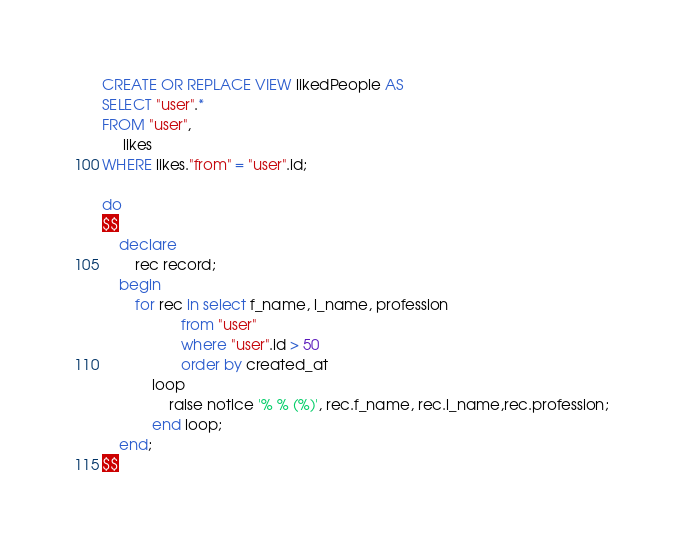Convert code to text. <code><loc_0><loc_0><loc_500><loc_500><_SQL_>CREATE OR REPLACE VIEW likedPeople AS
SELECT "user".*
FROM "user",
     likes
WHERE likes."from" = "user".id;

do
$$
    declare
        rec record;
    begin
        for rec in select f_name, l_name, profession
                   from "user"
                   where "user".id > 50
                   order by created_at
            loop
                raise notice '% % (%)', rec.f_name, rec.l_name,rec.profession;
            end loop;
    end;
$$</code> 